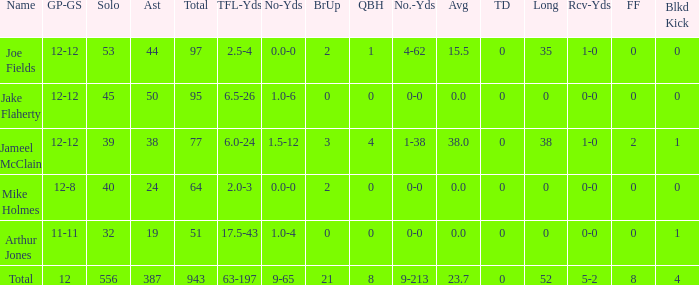How many tackle assists for the player who averages 23.7? 387.0. 